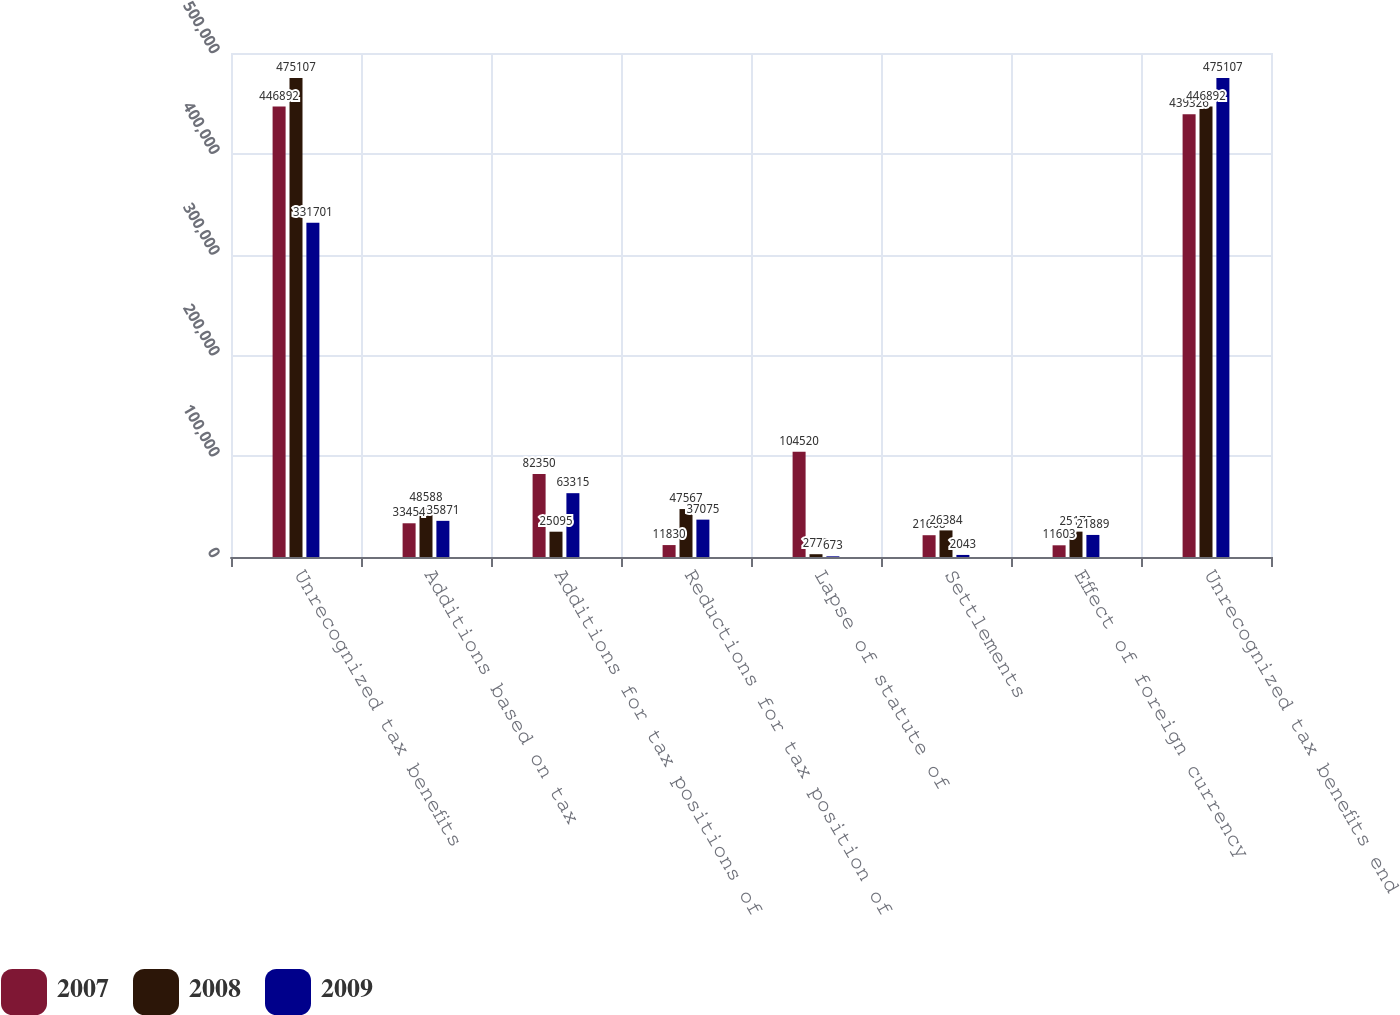Convert chart. <chart><loc_0><loc_0><loc_500><loc_500><stacked_bar_chart><ecel><fcel>Unrecognized tax benefits<fcel>Additions based on tax<fcel>Additions for tax positions of<fcel>Reductions for tax position of<fcel>Lapse of statute of<fcel>Settlements<fcel>Effect of foreign currency<fcel>Unrecognized tax benefits end<nl><fcel>2007<fcel>446892<fcel>33454<fcel>82350<fcel>11830<fcel>104520<fcel>21608<fcel>11603<fcel>439326<nl><fcel>2008<fcel>475107<fcel>48588<fcel>25095<fcel>47567<fcel>2772<fcel>26384<fcel>25175<fcel>446892<nl><fcel>2009<fcel>331701<fcel>35871<fcel>63315<fcel>37075<fcel>673<fcel>2043<fcel>21889<fcel>475107<nl></chart> 